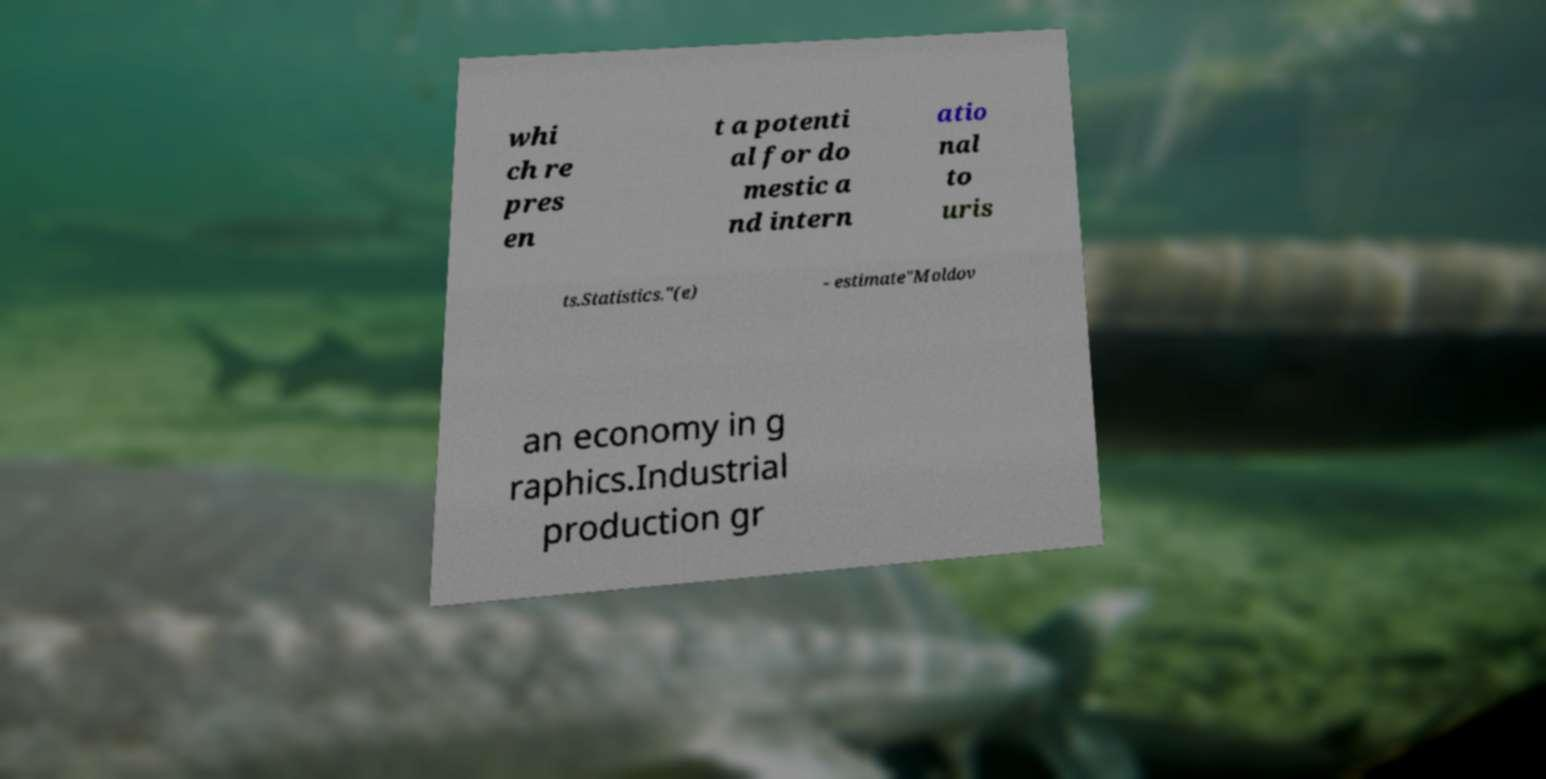Could you assist in decoding the text presented in this image and type it out clearly? whi ch re pres en t a potenti al for do mestic a nd intern atio nal to uris ts.Statistics."(e) - estimate"Moldov an economy in g raphics.Industrial production gr 